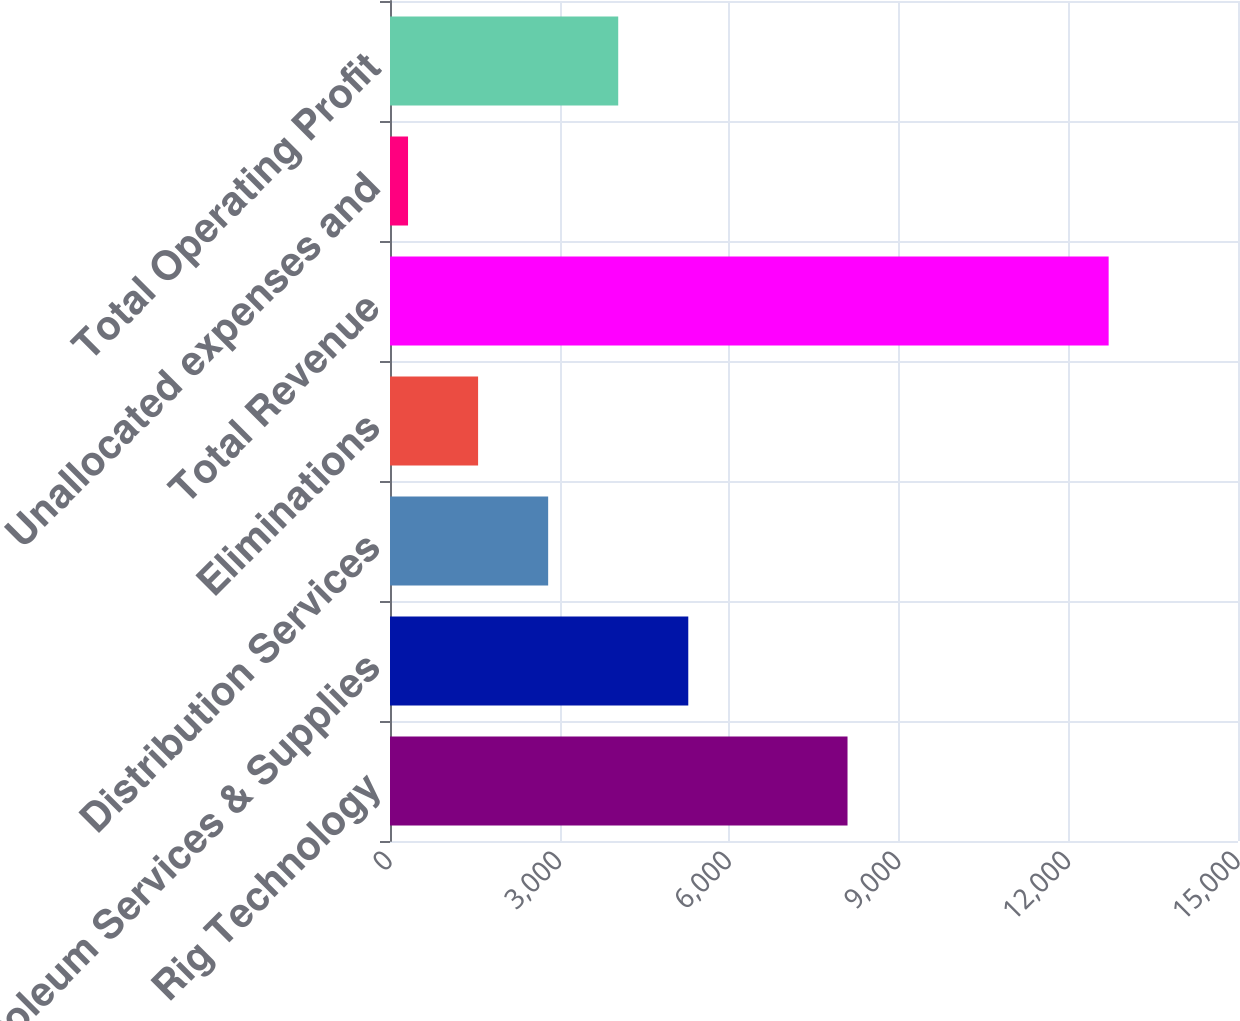Convert chart. <chart><loc_0><loc_0><loc_500><loc_500><bar_chart><fcel>Rig Technology<fcel>Petroleum Services & Supplies<fcel>Distribution Services<fcel>Eliminations<fcel>Total Revenue<fcel>Unallocated expenses and<fcel>Total Operating Profit<nl><fcel>8093<fcel>5276.2<fcel>2797.6<fcel>1558.3<fcel>12712<fcel>319<fcel>4036.9<nl></chart> 